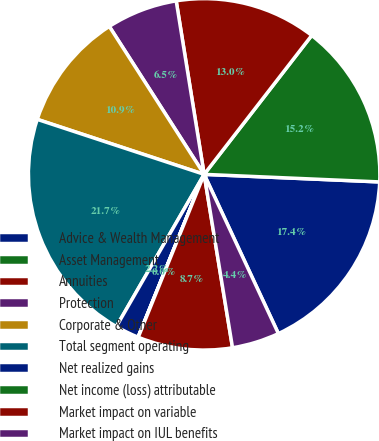Convert chart. <chart><loc_0><loc_0><loc_500><loc_500><pie_chart><fcel>Advice & Wealth Management<fcel>Asset Management<fcel>Annuities<fcel>Protection<fcel>Corporate & Other<fcel>Total segment operating<fcel>Net realized gains<fcel>Net income (loss) attributable<fcel>Market impact on variable<fcel>Market impact on IUL benefits<nl><fcel>17.37%<fcel>15.2%<fcel>13.03%<fcel>6.53%<fcel>10.86%<fcel>21.74%<fcel>2.19%<fcel>0.02%<fcel>8.7%<fcel>4.36%<nl></chart> 